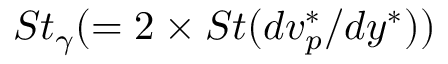Convert formula to latex. <formula><loc_0><loc_0><loc_500><loc_500>S t _ { \gamma } ( = 2 \times S t ( d v _ { p } ^ { * } / d y ^ { * } ) )</formula> 